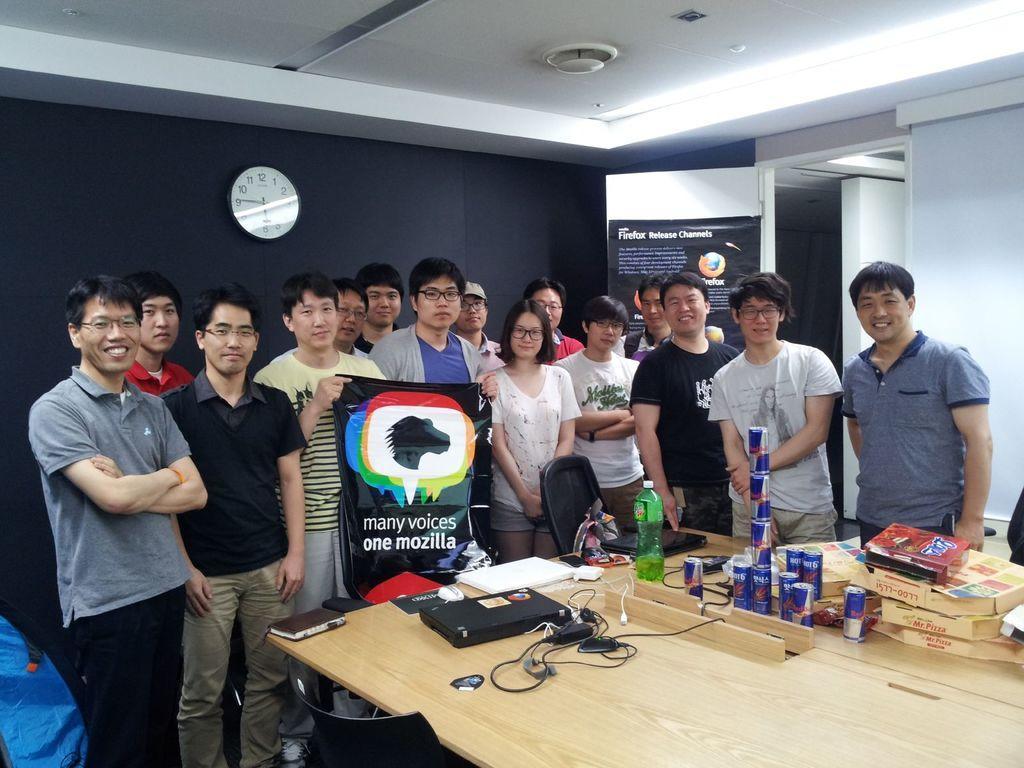In one or two sentences, can you explain what this image depicts? In this image in the center there are a group of people who are standing and one person is holding one board, at the bottom there is a table. On the table there are some laptops, coke containers, books, wires, bottle and some objects and also there is one chair. In the background there is a wall, on the wall there is one clock and one board. On the top there is ceiling. 